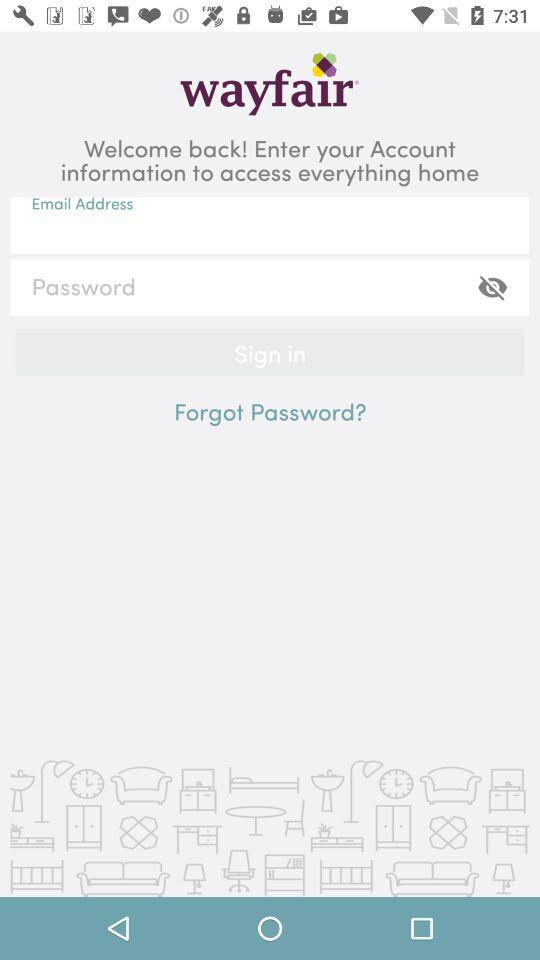What is the name of the application? The name of the application is "wayfair". 